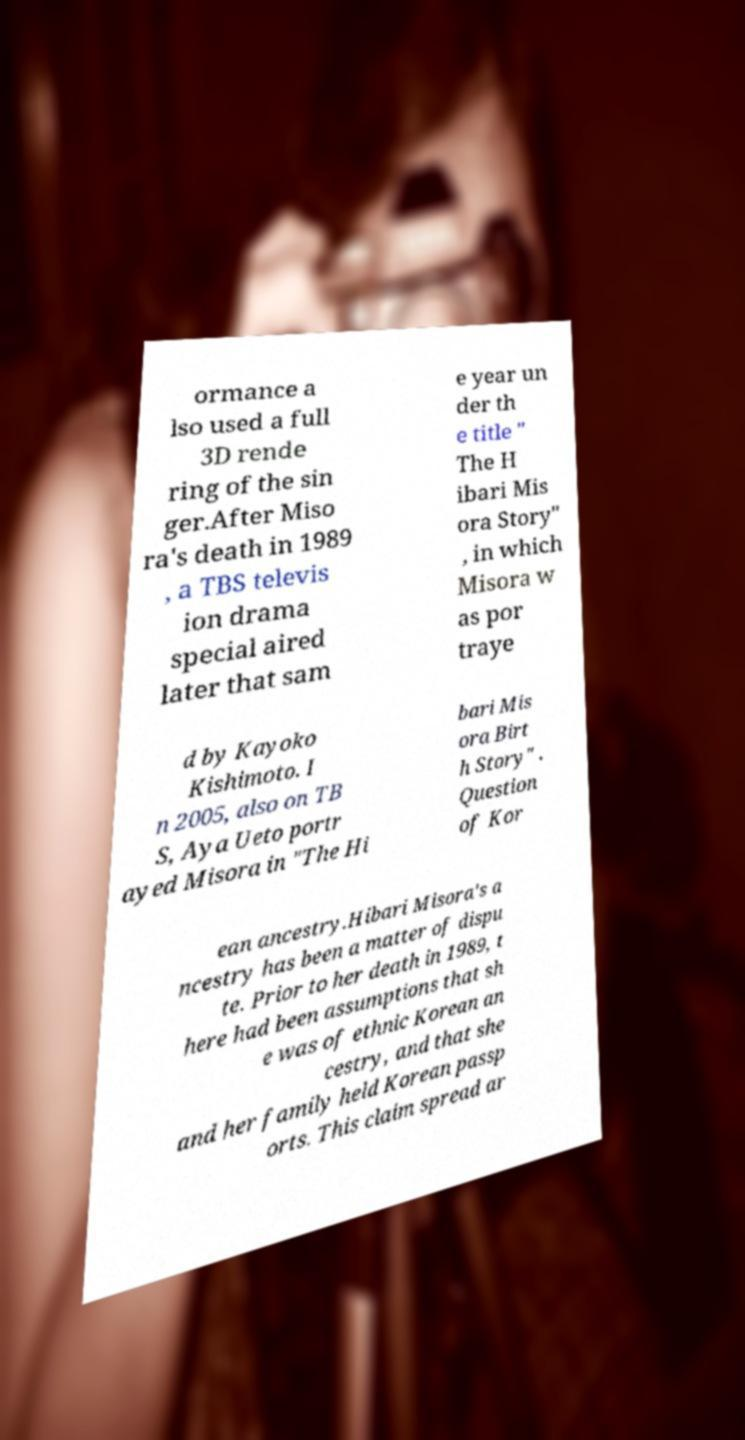Could you extract and type out the text from this image? ormance a lso used a full 3D rende ring of the sin ger.After Miso ra's death in 1989 , a TBS televis ion drama special aired later that sam e year un der th e title " The H ibari Mis ora Story" , in which Misora w as por traye d by Kayoko Kishimoto. I n 2005, also on TB S, Aya Ueto portr ayed Misora in "The Hi bari Mis ora Birt h Story" . Question of Kor ean ancestry.Hibari Misora's a ncestry has been a matter of dispu te. Prior to her death in 1989, t here had been assumptions that sh e was of ethnic Korean an cestry, and that she and her family held Korean passp orts. This claim spread ar 